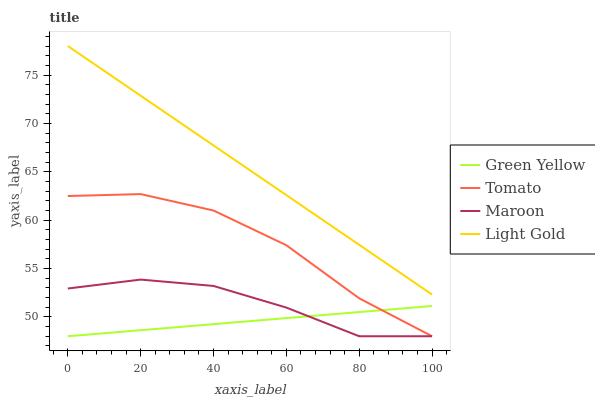Does Light Gold have the minimum area under the curve?
Answer yes or no. No. Does Green Yellow have the maximum area under the curve?
Answer yes or no. No. Is Light Gold the smoothest?
Answer yes or no. No. Is Light Gold the roughest?
Answer yes or no. No. Does Light Gold have the lowest value?
Answer yes or no. No. Does Green Yellow have the highest value?
Answer yes or no. No. Is Green Yellow less than Light Gold?
Answer yes or no. Yes. Is Light Gold greater than Maroon?
Answer yes or no. Yes. Does Green Yellow intersect Light Gold?
Answer yes or no. No. 